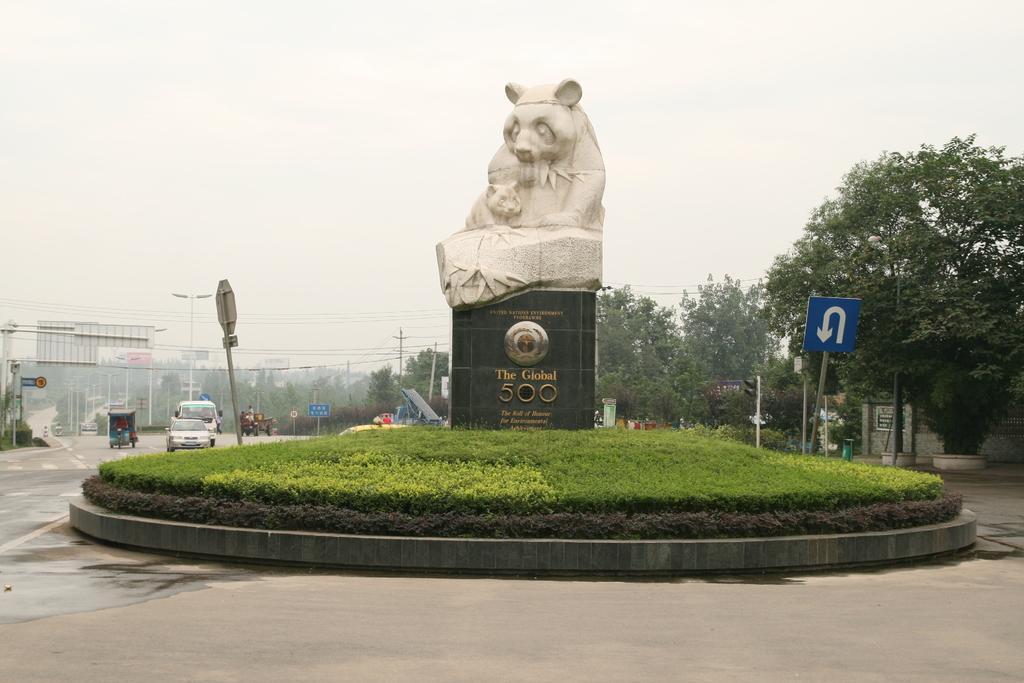How would you summarize this image in a sentence or two? In the middle of the picture, we see the statue of the bear. Beside that, we see the grass and we even see a direction board in blue color. On the left side of the picture, we see vehicles moving on the road. There are many trees, street lights, boards in the background. At the top of the picture, we see the sky and at the bottom of the picture, we see the road. This picture is clicked outside the city. 